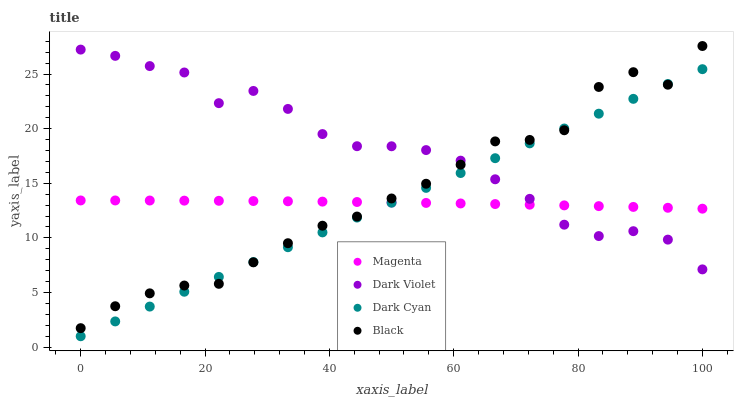Does Magenta have the minimum area under the curve?
Answer yes or no. Yes. Does Dark Violet have the maximum area under the curve?
Answer yes or no. Yes. Does Black have the minimum area under the curve?
Answer yes or no. No. Does Black have the maximum area under the curve?
Answer yes or no. No. Is Dark Cyan the smoothest?
Answer yes or no. Yes. Is Black the roughest?
Answer yes or no. Yes. Is Magenta the smoothest?
Answer yes or no. No. Is Magenta the roughest?
Answer yes or no. No. Does Dark Cyan have the lowest value?
Answer yes or no. Yes. Does Black have the lowest value?
Answer yes or no. No. Does Black have the highest value?
Answer yes or no. Yes. Does Magenta have the highest value?
Answer yes or no. No. Does Dark Cyan intersect Dark Violet?
Answer yes or no. Yes. Is Dark Cyan less than Dark Violet?
Answer yes or no. No. Is Dark Cyan greater than Dark Violet?
Answer yes or no. No. 